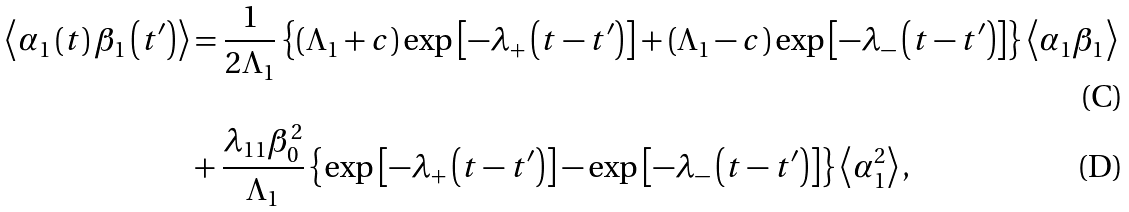<formula> <loc_0><loc_0><loc_500><loc_500>\left \langle \alpha _ { 1 } \left ( t \right ) \beta _ { 1 } \left ( t ^ { \prime } \right ) \right \rangle & = \frac { 1 } { 2 \Lambda _ { 1 } } \left \{ \left ( \Lambda _ { 1 } + c \right ) \exp \left [ - \lambda _ { + } \left ( t - t ^ { \prime } \right ) \right ] + \left ( \Lambda _ { 1 } - c \right ) \exp \left [ - \lambda _ { - } \left ( t - t ^ { \prime } \right ) \right ] \right \} \left \langle \alpha _ { 1 } \beta _ { 1 } \right \rangle \\ & + \frac { \lambda _ { 1 1 } \beta _ { 0 } ^ { 2 } } { \Lambda _ { 1 } } \left \{ \exp \left [ - \lambda _ { + } \left ( t - t ^ { \prime } \right ) \right ] - \exp \left [ - \lambda _ { - } \left ( t - t ^ { \prime } \right ) \right ] \right \} \left \langle \alpha _ { 1 } ^ { 2 } \right \rangle ,</formula> 